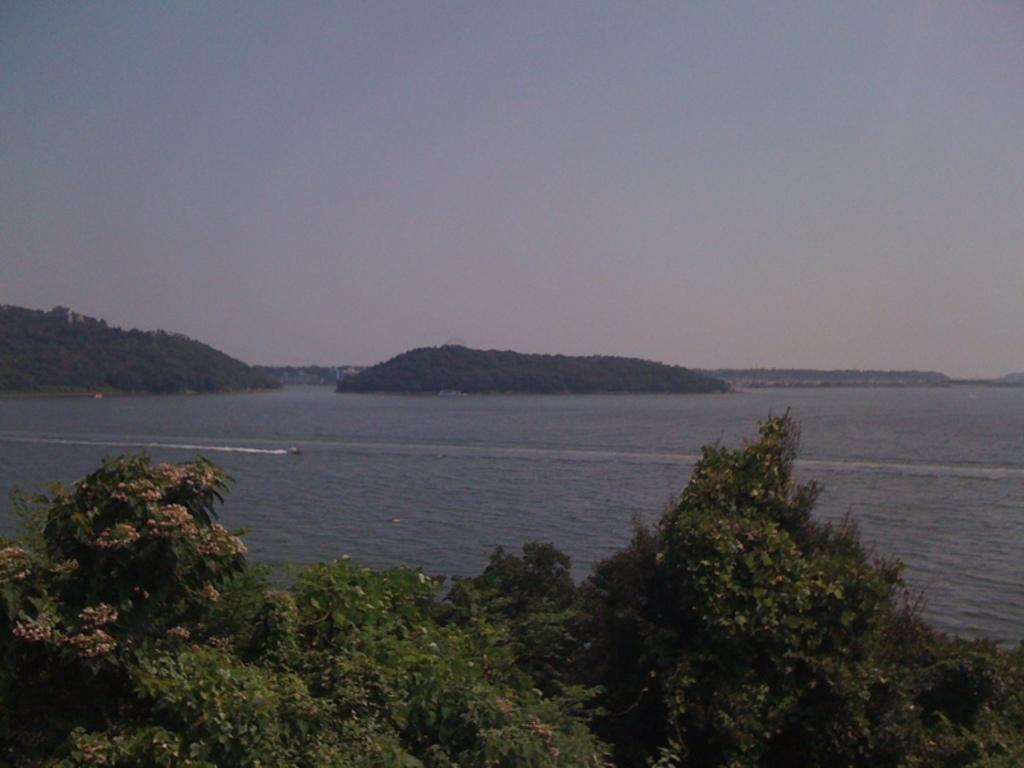What type of plants can be seen in the image? There are plants with flowers in the image. What else is visible in the image besides the plants? There is water visible in the image. What can be seen in the background of the image? There are hills and the sky visible in the background of the image. How many eyes can be seen on the plants in the image? There are no eyes visible on the plants in the image, as plants do not have eyes. 